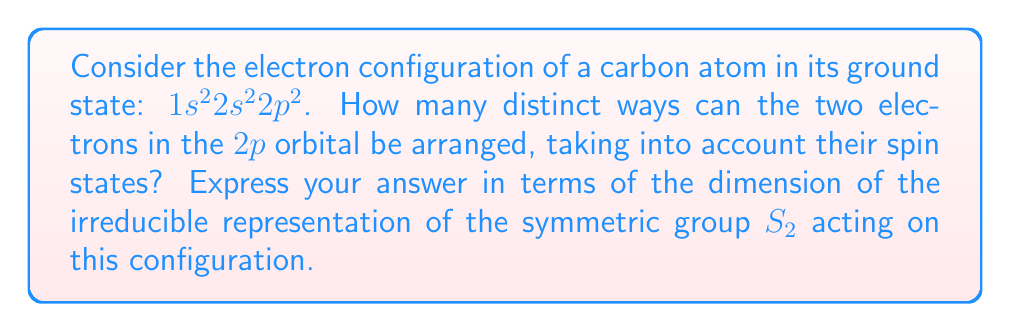What is the answer to this math problem? Let's approach this step-by-step:

1) First, recall that the $2p$ orbital can hold up to 6 electrons (2 in each of the $p_x$, $p_y$, and $p_z$ subshells).

2) In the ground state of carbon, we have 2 electrons in the $2p$ orbital.

3) Each electron can have one of two spin states: up ($\uparrow$) or down ($\downarrow$).

4) The symmetric group $S_2$ acts on these two electrons by permuting their positions.

5) The possible arrangements are:
   $$(\uparrow,\uparrow), (\uparrow,\downarrow), (\downarrow,\uparrow), (\downarrow,\downarrow)$$

6) However, electrons are fermions and must obey the Pauli exclusion principle. This means that no two electrons can have the same quantum numbers, including spin.

7) Therefore, the arrangement $(\uparrow,\uparrow)$ and $(\downarrow,\downarrow)$ are not allowed.

8) The remaining allowed arrangements are $(\uparrow,\downarrow)$ and $(\downarrow,\uparrow)$.

9) These two arrangements form a basis for the representation of $S_2$ acting on this electron configuration.

10) This representation is actually the sign representation of $S_2$, which is one-dimensional and irreducible.

11) Therefore, the number of distinct ways to arrange the electrons is equal to the dimension of this irreducible representation, which is 1.
Answer: 1 